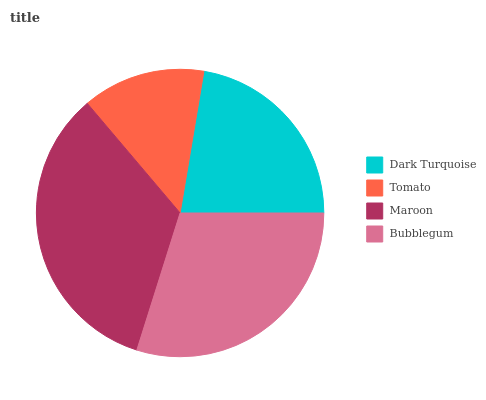Is Tomato the minimum?
Answer yes or no. Yes. Is Maroon the maximum?
Answer yes or no. Yes. Is Maroon the minimum?
Answer yes or no. No. Is Tomato the maximum?
Answer yes or no. No. Is Maroon greater than Tomato?
Answer yes or no. Yes. Is Tomato less than Maroon?
Answer yes or no. Yes. Is Tomato greater than Maroon?
Answer yes or no. No. Is Maroon less than Tomato?
Answer yes or no. No. Is Bubblegum the high median?
Answer yes or no. Yes. Is Dark Turquoise the low median?
Answer yes or no. Yes. Is Maroon the high median?
Answer yes or no. No. Is Bubblegum the low median?
Answer yes or no. No. 